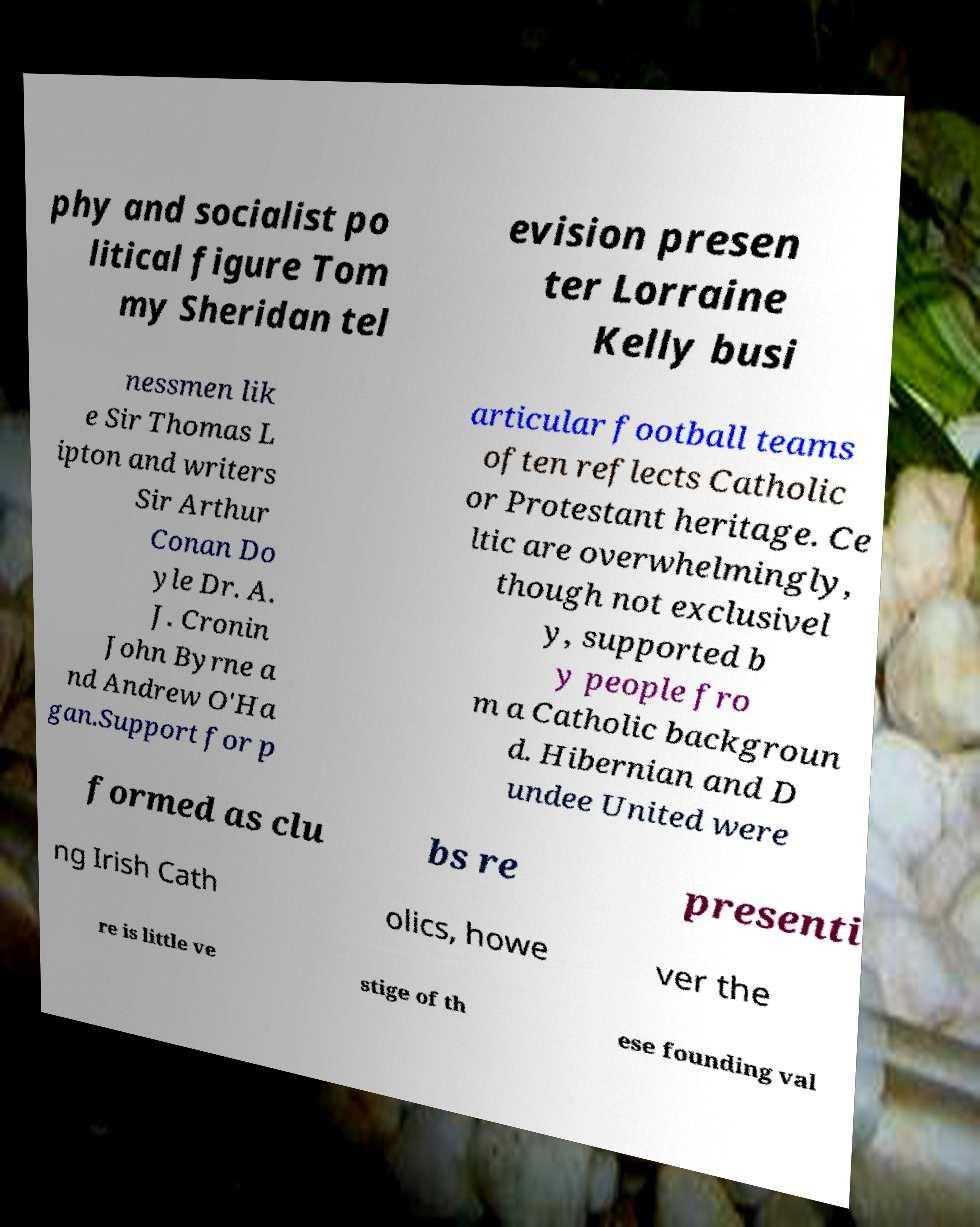What messages or text are displayed in this image? I need them in a readable, typed format. phy and socialist po litical figure Tom my Sheridan tel evision presen ter Lorraine Kelly busi nessmen lik e Sir Thomas L ipton and writers Sir Arthur Conan Do yle Dr. A. J. Cronin John Byrne a nd Andrew O'Ha gan.Support for p articular football teams often reflects Catholic or Protestant heritage. Ce ltic are overwhelmingly, though not exclusivel y, supported b y people fro m a Catholic backgroun d. Hibernian and D undee United were formed as clu bs re presenti ng Irish Cath olics, howe ver the re is little ve stige of th ese founding val 